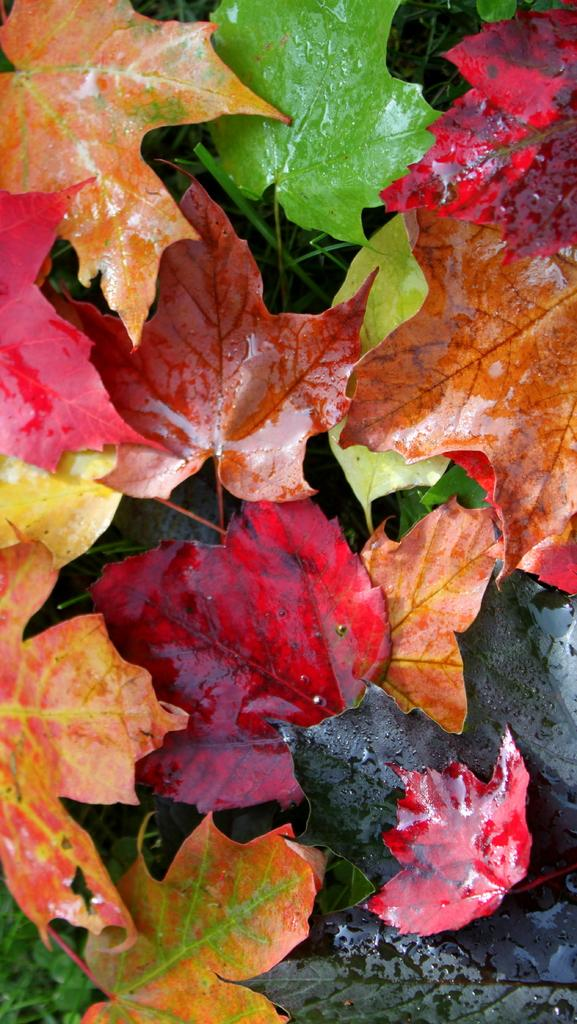What is the primary subject of the image? The image contains many leaves in different colors, and the leaves are the main focus of the image. Can you describe the background of the image? There is grass at the bottom of the image. How close is the camera to the leaves in the image? The image appears to be zoomed in. Can you see a beetle crawling on the top of the leaves in the image? There is no beetle present in the image. Who is the servant attending to in the image? There is no servant or person present in the image; it only contains leaves and grass. 